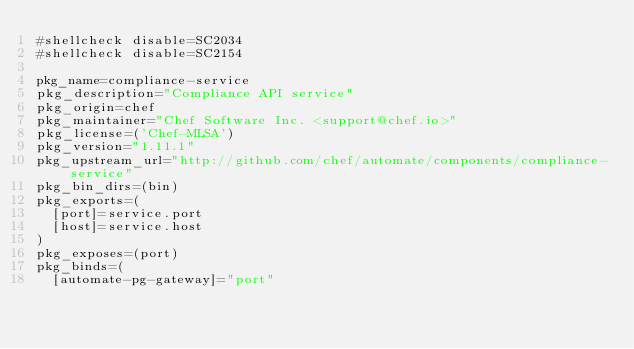<code> <loc_0><loc_0><loc_500><loc_500><_Bash_>#shellcheck disable=SC2034
#shellcheck disable=SC2154

pkg_name=compliance-service
pkg_description="Compliance API service"
pkg_origin=chef
pkg_maintainer="Chef Software Inc. <support@chef.io>"
pkg_license=('Chef-MLSA')
pkg_version="1.11.1"
pkg_upstream_url="http://github.com/chef/automate/components/compliance-service"
pkg_bin_dirs=(bin)
pkg_exports=(
  [port]=service.port
  [host]=service.host
)
pkg_exposes=(port)
pkg_binds=(
  [automate-pg-gateway]="port"</code> 